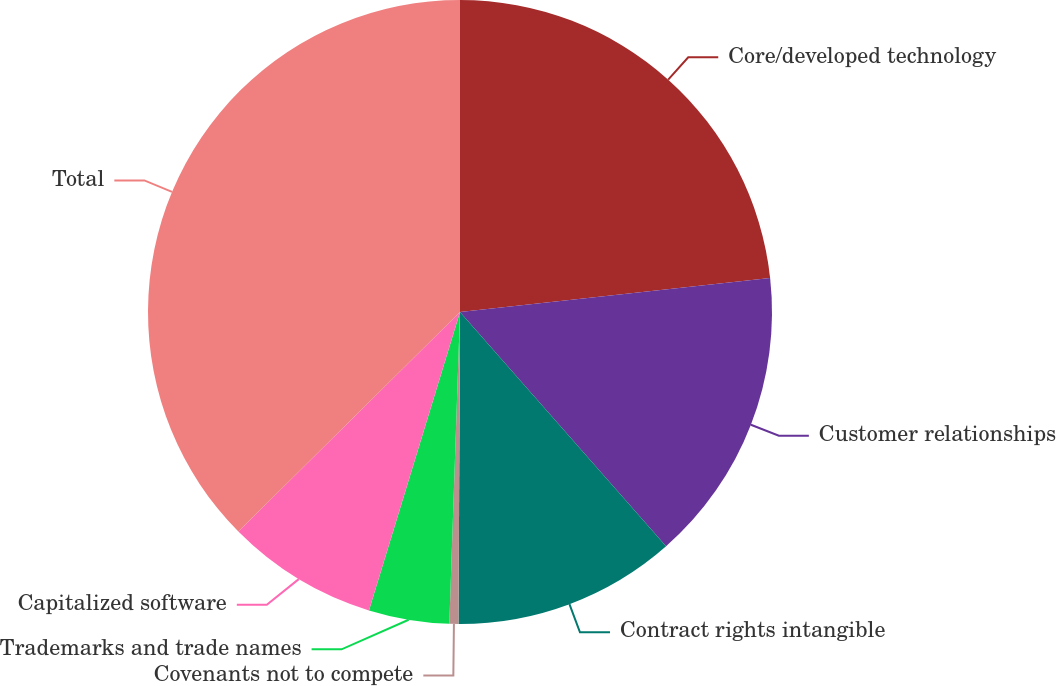<chart> <loc_0><loc_0><loc_500><loc_500><pie_chart><fcel>Core/developed technology<fcel>Customer relationships<fcel>Contract rights intangible<fcel>Covenants not to compete<fcel>Trademarks and trade names<fcel>Capitalized software<fcel>Total<nl><fcel>23.26%<fcel>15.26%<fcel>11.56%<fcel>0.47%<fcel>4.17%<fcel>7.86%<fcel>37.43%<nl></chart> 